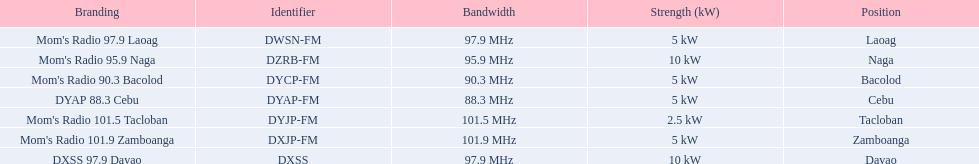What is the last location on this chart? Davao. 